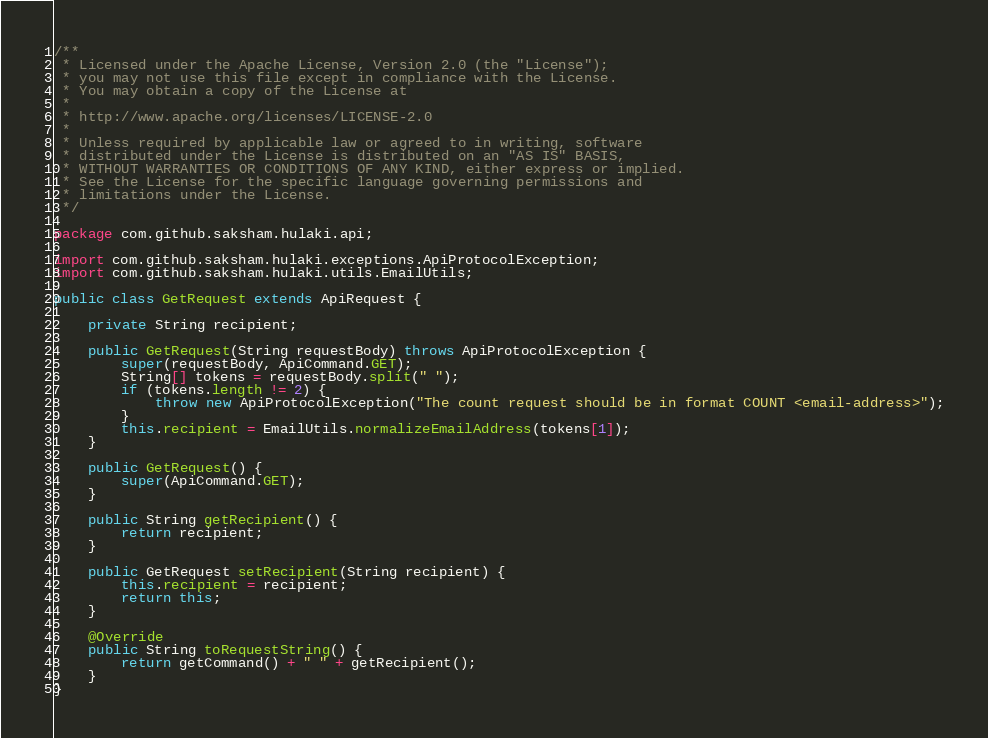Convert code to text. <code><loc_0><loc_0><loc_500><loc_500><_Java_>/**
 * Licensed under the Apache License, Version 2.0 (the "License");
 * you may not use this file except in compliance with the License.
 * You may obtain a copy of the License at
 *
 * http://www.apache.org/licenses/LICENSE-2.0
 *
 * Unless required by applicable law or agreed to in writing, software
 * distributed under the License is distributed on an "AS IS" BASIS,
 * WITHOUT WARRANTIES OR CONDITIONS OF ANY KIND, either express or implied.
 * See the License for the specific language governing permissions and
 * limitations under the License.
 */

package com.github.saksham.hulaki.api;

import com.github.saksham.hulaki.exceptions.ApiProtocolException;
import com.github.saksham.hulaki.utils.EmailUtils;

public class GetRequest extends ApiRequest {

    private String recipient;

    public GetRequest(String requestBody) throws ApiProtocolException {
        super(requestBody, ApiCommand.GET);
        String[] tokens = requestBody.split(" ");
        if (tokens.length != 2) {
            throw new ApiProtocolException("The count request should be in format COUNT <email-address>");
        }
        this.recipient = EmailUtils.normalizeEmailAddress(tokens[1]);
    }

    public GetRequest() {
        super(ApiCommand.GET);
    }

    public String getRecipient() {
        return recipient;
    }

    public GetRequest setRecipient(String recipient) {
        this.recipient = recipient;
        return this;
    }

    @Override
    public String toRequestString() {
        return getCommand() + " " + getRecipient();
    }
}
</code> 